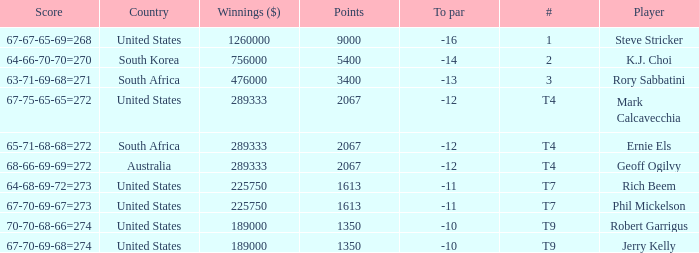Name the number of points for south korea 1.0. 